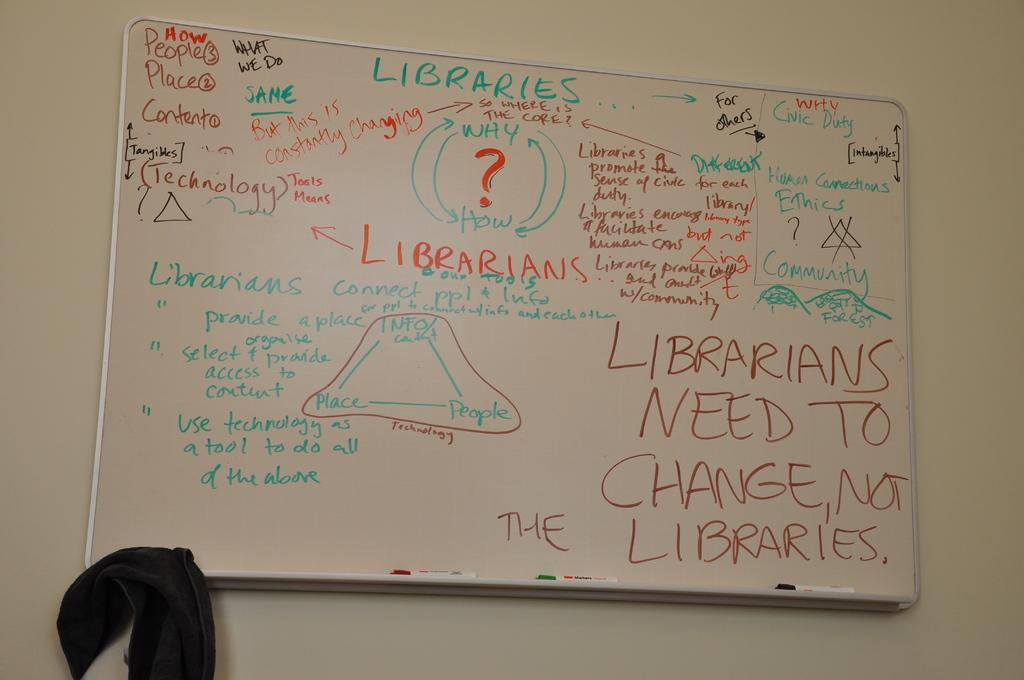Provide a one-sentence caption for the provided image. A white board with a lot of writing, mostly saying library jargon. 